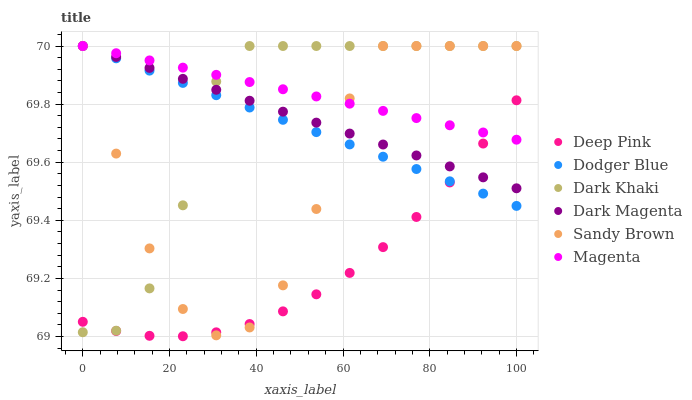Does Deep Pink have the minimum area under the curve?
Answer yes or no. Yes. Does Magenta have the maximum area under the curve?
Answer yes or no. Yes. Does Dark Magenta have the minimum area under the curve?
Answer yes or no. No. Does Dark Magenta have the maximum area under the curve?
Answer yes or no. No. Is Dark Magenta the smoothest?
Answer yes or no. Yes. Is Sandy Brown the roughest?
Answer yes or no. Yes. Is Dark Khaki the smoothest?
Answer yes or no. No. Is Dark Khaki the roughest?
Answer yes or no. No. Does Deep Pink have the lowest value?
Answer yes or no. Yes. Does Dark Magenta have the lowest value?
Answer yes or no. No. Does Sandy Brown have the highest value?
Answer yes or no. Yes. Does Magenta intersect Sandy Brown?
Answer yes or no. Yes. Is Magenta less than Sandy Brown?
Answer yes or no. No. Is Magenta greater than Sandy Brown?
Answer yes or no. No. 